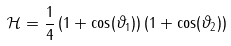Convert formula to latex. <formula><loc_0><loc_0><loc_500><loc_500>\mathcal { H } = \frac { 1 } { 4 } \left ( 1 + \cos ( \vartheta _ { 1 } ) \right ) \left ( 1 + \cos ( \vartheta _ { 2 } ) \right )</formula> 